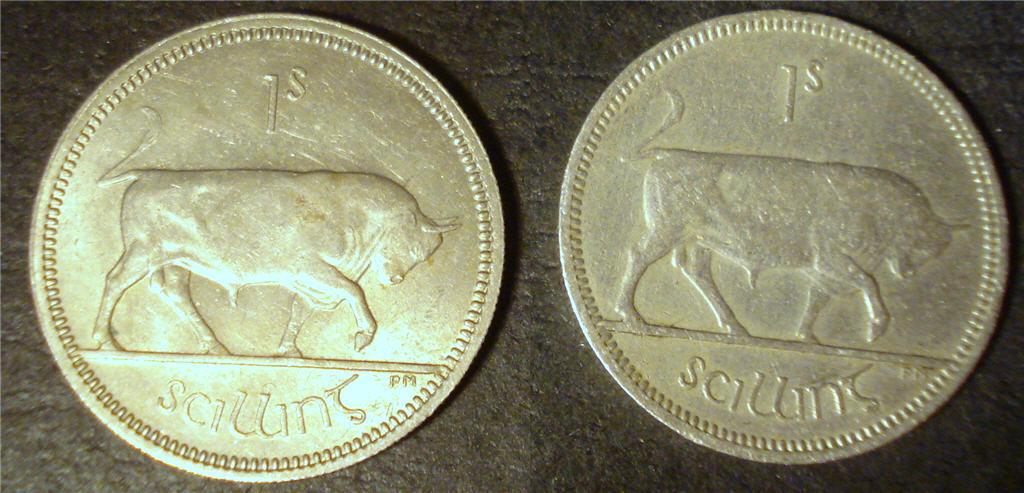Provide a one-sentence caption for the provided image. two coins next to each other that say 1s and sciuins. 